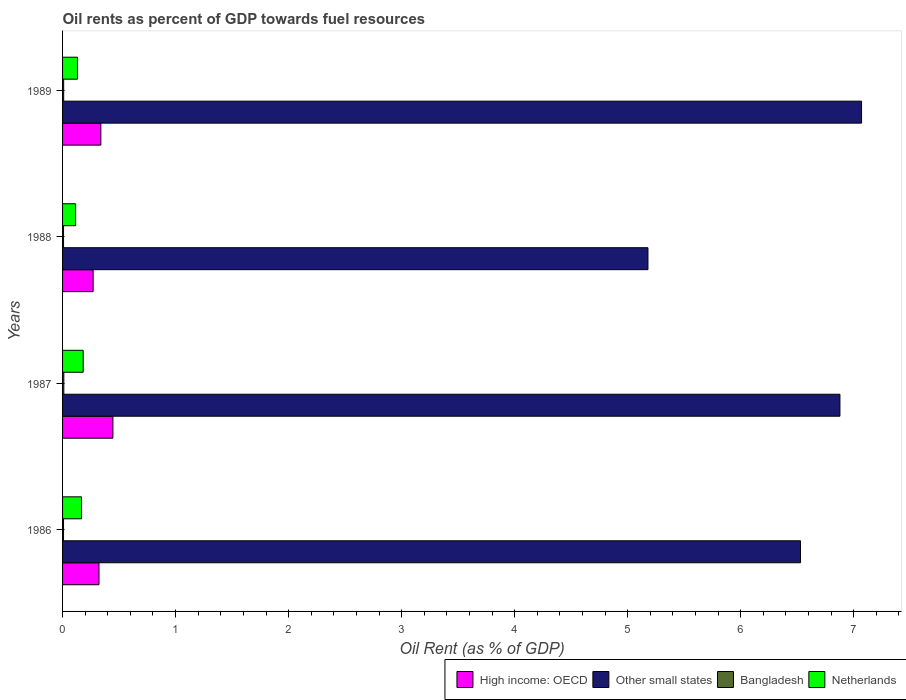How many different coloured bars are there?
Ensure brevity in your answer.  4. How many groups of bars are there?
Give a very brief answer. 4. How many bars are there on the 2nd tick from the bottom?
Offer a terse response. 4. In how many cases, is the number of bars for a given year not equal to the number of legend labels?
Your answer should be compact. 0. What is the oil rent in Netherlands in 1987?
Offer a terse response. 0.18. Across all years, what is the maximum oil rent in Other small states?
Give a very brief answer. 7.07. Across all years, what is the minimum oil rent in Other small states?
Provide a succinct answer. 5.18. In which year was the oil rent in Bangladesh maximum?
Your answer should be very brief. 1987. In which year was the oil rent in High income: OECD minimum?
Keep it short and to the point. 1988. What is the total oil rent in High income: OECD in the graph?
Your response must be concise. 1.38. What is the difference between the oil rent in Other small states in 1986 and that in 1989?
Keep it short and to the point. -0.54. What is the difference between the oil rent in Netherlands in 1988 and the oil rent in High income: OECD in 1986?
Your response must be concise. -0.21. What is the average oil rent in Netherlands per year?
Offer a very short reply. 0.15. In the year 1987, what is the difference between the oil rent in Netherlands and oil rent in Other small states?
Offer a terse response. -6.7. In how many years, is the oil rent in Other small states greater than 7 %?
Give a very brief answer. 1. What is the ratio of the oil rent in Netherlands in 1986 to that in 1988?
Your response must be concise. 1.45. Is the difference between the oil rent in Netherlands in 1986 and 1989 greater than the difference between the oil rent in Other small states in 1986 and 1989?
Your answer should be very brief. Yes. What is the difference between the highest and the second highest oil rent in Other small states?
Provide a short and direct response. 0.19. What is the difference between the highest and the lowest oil rent in High income: OECD?
Offer a terse response. 0.18. In how many years, is the oil rent in Bangladesh greater than the average oil rent in Bangladesh taken over all years?
Your answer should be compact. 2. What does the 1st bar from the top in 1988 represents?
Offer a very short reply. Netherlands. What does the 2nd bar from the bottom in 1986 represents?
Your answer should be compact. Other small states. Is it the case that in every year, the sum of the oil rent in High income: OECD and oil rent in Other small states is greater than the oil rent in Bangladesh?
Your answer should be very brief. Yes. How many bars are there?
Give a very brief answer. 16. Are all the bars in the graph horizontal?
Provide a short and direct response. Yes. How many years are there in the graph?
Keep it short and to the point. 4. Are the values on the major ticks of X-axis written in scientific E-notation?
Provide a short and direct response. No. Does the graph contain any zero values?
Keep it short and to the point. No. Does the graph contain grids?
Provide a succinct answer. No. Where does the legend appear in the graph?
Provide a short and direct response. Bottom right. How are the legend labels stacked?
Your answer should be compact. Horizontal. What is the title of the graph?
Make the answer very short. Oil rents as percent of GDP towards fuel resources. What is the label or title of the X-axis?
Provide a short and direct response. Oil Rent (as % of GDP). What is the Oil Rent (as % of GDP) of High income: OECD in 1986?
Offer a very short reply. 0.32. What is the Oil Rent (as % of GDP) of Other small states in 1986?
Provide a succinct answer. 6.53. What is the Oil Rent (as % of GDP) of Bangladesh in 1986?
Make the answer very short. 0.01. What is the Oil Rent (as % of GDP) in Netherlands in 1986?
Ensure brevity in your answer.  0.17. What is the Oil Rent (as % of GDP) in High income: OECD in 1987?
Ensure brevity in your answer.  0.45. What is the Oil Rent (as % of GDP) in Other small states in 1987?
Provide a short and direct response. 6.88. What is the Oil Rent (as % of GDP) in Bangladesh in 1987?
Give a very brief answer. 0.01. What is the Oil Rent (as % of GDP) in Netherlands in 1987?
Give a very brief answer. 0.18. What is the Oil Rent (as % of GDP) in High income: OECD in 1988?
Ensure brevity in your answer.  0.27. What is the Oil Rent (as % of GDP) of Other small states in 1988?
Your answer should be very brief. 5.18. What is the Oil Rent (as % of GDP) in Bangladesh in 1988?
Keep it short and to the point. 0.01. What is the Oil Rent (as % of GDP) of Netherlands in 1988?
Offer a terse response. 0.12. What is the Oil Rent (as % of GDP) in High income: OECD in 1989?
Give a very brief answer. 0.34. What is the Oil Rent (as % of GDP) in Other small states in 1989?
Provide a short and direct response. 7.07. What is the Oil Rent (as % of GDP) of Bangladesh in 1989?
Offer a very short reply. 0.01. What is the Oil Rent (as % of GDP) in Netherlands in 1989?
Make the answer very short. 0.13. Across all years, what is the maximum Oil Rent (as % of GDP) of High income: OECD?
Provide a short and direct response. 0.45. Across all years, what is the maximum Oil Rent (as % of GDP) in Other small states?
Provide a short and direct response. 7.07. Across all years, what is the maximum Oil Rent (as % of GDP) of Bangladesh?
Offer a terse response. 0.01. Across all years, what is the maximum Oil Rent (as % of GDP) in Netherlands?
Your answer should be compact. 0.18. Across all years, what is the minimum Oil Rent (as % of GDP) in High income: OECD?
Your answer should be very brief. 0.27. Across all years, what is the minimum Oil Rent (as % of GDP) of Other small states?
Provide a short and direct response. 5.18. Across all years, what is the minimum Oil Rent (as % of GDP) in Bangladesh?
Your answer should be compact. 0.01. Across all years, what is the minimum Oil Rent (as % of GDP) of Netherlands?
Make the answer very short. 0.12. What is the total Oil Rent (as % of GDP) in High income: OECD in the graph?
Offer a very short reply. 1.38. What is the total Oil Rent (as % of GDP) in Other small states in the graph?
Ensure brevity in your answer.  25.65. What is the total Oil Rent (as % of GDP) of Bangladesh in the graph?
Your answer should be compact. 0.04. What is the total Oil Rent (as % of GDP) of Netherlands in the graph?
Your answer should be compact. 0.6. What is the difference between the Oil Rent (as % of GDP) in High income: OECD in 1986 and that in 1987?
Give a very brief answer. -0.12. What is the difference between the Oil Rent (as % of GDP) of Other small states in 1986 and that in 1987?
Make the answer very short. -0.35. What is the difference between the Oil Rent (as % of GDP) in Bangladesh in 1986 and that in 1987?
Your answer should be compact. -0. What is the difference between the Oil Rent (as % of GDP) of Netherlands in 1986 and that in 1987?
Your answer should be compact. -0.01. What is the difference between the Oil Rent (as % of GDP) in High income: OECD in 1986 and that in 1988?
Your response must be concise. 0.05. What is the difference between the Oil Rent (as % of GDP) in Other small states in 1986 and that in 1988?
Keep it short and to the point. 1.35. What is the difference between the Oil Rent (as % of GDP) in Bangladesh in 1986 and that in 1988?
Make the answer very short. -0. What is the difference between the Oil Rent (as % of GDP) in Netherlands in 1986 and that in 1988?
Offer a terse response. 0.05. What is the difference between the Oil Rent (as % of GDP) of High income: OECD in 1986 and that in 1989?
Provide a short and direct response. -0.02. What is the difference between the Oil Rent (as % of GDP) of Other small states in 1986 and that in 1989?
Your answer should be compact. -0.54. What is the difference between the Oil Rent (as % of GDP) in Bangladesh in 1986 and that in 1989?
Offer a very short reply. -0. What is the difference between the Oil Rent (as % of GDP) in Netherlands in 1986 and that in 1989?
Your answer should be compact. 0.04. What is the difference between the Oil Rent (as % of GDP) in High income: OECD in 1987 and that in 1988?
Your response must be concise. 0.17. What is the difference between the Oil Rent (as % of GDP) in Other small states in 1987 and that in 1988?
Provide a succinct answer. 1.7. What is the difference between the Oil Rent (as % of GDP) of Bangladesh in 1987 and that in 1988?
Your answer should be compact. 0. What is the difference between the Oil Rent (as % of GDP) in Netherlands in 1987 and that in 1988?
Give a very brief answer. 0.07. What is the difference between the Oil Rent (as % of GDP) in High income: OECD in 1987 and that in 1989?
Your response must be concise. 0.11. What is the difference between the Oil Rent (as % of GDP) of Other small states in 1987 and that in 1989?
Ensure brevity in your answer.  -0.19. What is the difference between the Oil Rent (as % of GDP) of Bangladesh in 1987 and that in 1989?
Your response must be concise. 0. What is the difference between the Oil Rent (as % of GDP) of Netherlands in 1987 and that in 1989?
Your answer should be compact. 0.05. What is the difference between the Oil Rent (as % of GDP) in High income: OECD in 1988 and that in 1989?
Make the answer very short. -0.07. What is the difference between the Oil Rent (as % of GDP) in Other small states in 1988 and that in 1989?
Make the answer very short. -1.89. What is the difference between the Oil Rent (as % of GDP) of Bangladesh in 1988 and that in 1989?
Provide a succinct answer. -0. What is the difference between the Oil Rent (as % of GDP) in Netherlands in 1988 and that in 1989?
Your response must be concise. -0.02. What is the difference between the Oil Rent (as % of GDP) of High income: OECD in 1986 and the Oil Rent (as % of GDP) of Other small states in 1987?
Ensure brevity in your answer.  -6.56. What is the difference between the Oil Rent (as % of GDP) in High income: OECD in 1986 and the Oil Rent (as % of GDP) in Bangladesh in 1987?
Give a very brief answer. 0.31. What is the difference between the Oil Rent (as % of GDP) of High income: OECD in 1986 and the Oil Rent (as % of GDP) of Netherlands in 1987?
Provide a short and direct response. 0.14. What is the difference between the Oil Rent (as % of GDP) of Other small states in 1986 and the Oil Rent (as % of GDP) of Bangladesh in 1987?
Ensure brevity in your answer.  6.52. What is the difference between the Oil Rent (as % of GDP) of Other small states in 1986 and the Oil Rent (as % of GDP) of Netherlands in 1987?
Provide a succinct answer. 6.35. What is the difference between the Oil Rent (as % of GDP) in Bangladesh in 1986 and the Oil Rent (as % of GDP) in Netherlands in 1987?
Offer a very short reply. -0.17. What is the difference between the Oil Rent (as % of GDP) in High income: OECD in 1986 and the Oil Rent (as % of GDP) in Other small states in 1988?
Make the answer very short. -4.86. What is the difference between the Oil Rent (as % of GDP) in High income: OECD in 1986 and the Oil Rent (as % of GDP) in Bangladesh in 1988?
Offer a terse response. 0.31. What is the difference between the Oil Rent (as % of GDP) of High income: OECD in 1986 and the Oil Rent (as % of GDP) of Netherlands in 1988?
Your answer should be compact. 0.21. What is the difference between the Oil Rent (as % of GDP) of Other small states in 1986 and the Oil Rent (as % of GDP) of Bangladesh in 1988?
Offer a very short reply. 6.52. What is the difference between the Oil Rent (as % of GDP) of Other small states in 1986 and the Oil Rent (as % of GDP) of Netherlands in 1988?
Provide a short and direct response. 6.41. What is the difference between the Oil Rent (as % of GDP) of Bangladesh in 1986 and the Oil Rent (as % of GDP) of Netherlands in 1988?
Ensure brevity in your answer.  -0.11. What is the difference between the Oil Rent (as % of GDP) of High income: OECD in 1986 and the Oil Rent (as % of GDP) of Other small states in 1989?
Your answer should be very brief. -6.75. What is the difference between the Oil Rent (as % of GDP) in High income: OECD in 1986 and the Oil Rent (as % of GDP) in Bangladesh in 1989?
Make the answer very short. 0.31. What is the difference between the Oil Rent (as % of GDP) of High income: OECD in 1986 and the Oil Rent (as % of GDP) of Netherlands in 1989?
Ensure brevity in your answer.  0.19. What is the difference between the Oil Rent (as % of GDP) of Other small states in 1986 and the Oil Rent (as % of GDP) of Bangladesh in 1989?
Offer a very short reply. 6.52. What is the difference between the Oil Rent (as % of GDP) of Other small states in 1986 and the Oil Rent (as % of GDP) of Netherlands in 1989?
Ensure brevity in your answer.  6.4. What is the difference between the Oil Rent (as % of GDP) in Bangladesh in 1986 and the Oil Rent (as % of GDP) in Netherlands in 1989?
Make the answer very short. -0.12. What is the difference between the Oil Rent (as % of GDP) in High income: OECD in 1987 and the Oil Rent (as % of GDP) in Other small states in 1988?
Make the answer very short. -4.73. What is the difference between the Oil Rent (as % of GDP) in High income: OECD in 1987 and the Oil Rent (as % of GDP) in Bangladesh in 1988?
Your answer should be very brief. 0.44. What is the difference between the Oil Rent (as % of GDP) of High income: OECD in 1987 and the Oil Rent (as % of GDP) of Netherlands in 1988?
Your answer should be very brief. 0.33. What is the difference between the Oil Rent (as % of GDP) in Other small states in 1987 and the Oil Rent (as % of GDP) in Bangladesh in 1988?
Offer a terse response. 6.87. What is the difference between the Oil Rent (as % of GDP) of Other small states in 1987 and the Oil Rent (as % of GDP) of Netherlands in 1988?
Provide a succinct answer. 6.76. What is the difference between the Oil Rent (as % of GDP) of Bangladesh in 1987 and the Oil Rent (as % of GDP) of Netherlands in 1988?
Make the answer very short. -0.1. What is the difference between the Oil Rent (as % of GDP) of High income: OECD in 1987 and the Oil Rent (as % of GDP) of Other small states in 1989?
Ensure brevity in your answer.  -6.62. What is the difference between the Oil Rent (as % of GDP) in High income: OECD in 1987 and the Oil Rent (as % of GDP) in Bangladesh in 1989?
Your answer should be compact. 0.44. What is the difference between the Oil Rent (as % of GDP) of High income: OECD in 1987 and the Oil Rent (as % of GDP) of Netherlands in 1989?
Your answer should be compact. 0.31. What is the difference between the Oil Rent (as % of GDP) of Other small states in 1987 and the Oil Rent (as % of GDP) of Bangladesh in 1989?
Provide a short and direct response. 6.87. What is the difference between the Oil Rent (as % of GDP) of Other small states in 1987 and the Oil Rent (as % of GDP) of Netherlands in 1989?
Provide a short and direct response. 6.75. What is the difference between the Oil Rent (as % of GDP) in Bangladesh in 1987 and the Oil Rent (as % of GDP) in Netherlands in 1989?
Your answer should be very brief. -0.12. What is the difference between the Oil Rent (as % of GDP) in High income: OECD in 1988 and the Oil Rent (as % of GDP) in Other small states in 1989?
Give a very brief answer. -6.8. What is the difference between the Oil Rent (as % of GDP) in High income: OECD in 1988 and the Oil Rent (as % of GDP) in Bangladesh in 1989?
Your answer should be compact. 0.26. What is the difference between the Oil Rent (as % of GDP) in High income: OECD in 1988 and the Oil Rent (as % of GDP) in Netherlands in 1989?
Your answer should be compact. 0.14. What is the difference between the Oil Rent (as % of GDP) in Other small states in 1988 and the Oil Rent (as % of GDP) in Bangladesh in 1989?
Keep it short and to the point. 5.17. What is the difference between the Oil Rent (as % of GDP) in Other small states in 1988 and the Oil Rent (as % of GDP) in Netherlands in 1989?
Give a very brief answer. 5.05. What is the difference between the Oil Rent (as % of GDP) in Bangladesh in 1988 and the Oil Rent (as % of GDP) in Netherlands in 1989?
Provide a short and direct response. -0.12. What is the average Oil Rent (as % of GDP) of High income: OECD per year?
Provide a short and direct response. 0.34. What is the average Oil Rent (as % of GDP) in Other small states per year?
Your answer should be very brief. 6.41. What is the average Oil Rent (as % of GDP) in Bangladesh per year?
Make the answer very short. 0.01. What is the average Oil Rent (as % of GDP) of Netherlands per year?
Keep it short and to the point. 0.15. In the year 1986, what is the difference between the Oil Rent (as % of GDP) of High income: OECD and Oil Rent (as % of GDP) of Other small states?
Ensure brevity in your answer.  -6.21. In the year 1986, what is the difference between the Oil Rent (as % of GDP) in High income: OECD and Oil Rent (as % of GDP) in Bangladesh?
Give a very brief answer. 0.31. In the year 1986, what is the difference between the Oil Rent (as % of GDP) of High income: OECD and Oil Rent (as % of GDP) of Netherlands?
Ensure brevity in your answer.  0.15. In the year 1986, what is the difference between the Oil Rent (as % of GDP) in Other small states and Oil Rent (as % of GDP) in Bangladesh?
Your answer should be compact. 6.52. In the year 1986, what is the difference between the Oil Rent (as % of GDP) of Other small states and Oil Rent (as % of GDP) of Netherlands?
Your response must be concise. 6.36. In the year 1986, what is the difference between the Oil Rent (as % of GDP) of Bangladesh and Oil Rent (as % of GDP) of Netherlands?
Offer a terse response. -0.16. In the year 1987, what is the difference between the Oil Rent (as % of GDP) of High income: OECD and Oil Rent (as % of GDP) of Other small states?
Offer a terse response. -6.43. In the year 1987, what is the difference between the Oil Rent (as % of GDP) of High income: OECD and Oil Rent (as % of GDP) of Bangladesh?
Your response must be concise. 0.43. In the year 1987, what is the difference between the Oil Rent (as % of GDP) in High income: OECD and Oil Rent (as % of GDP) in Netherlands?
Offer a very short reply. 0.26. In the year 1987, what is the difference between the Oil Rent (as % of GDP) in Other small states and Oil Rent (as % of GDP) in Bangladesh?
Provide a succinct answer. 6.87. In the year 1987, what is the difference between the Oil Rent (as % of GDP) in Other small states and Oil Rent (as % of GDP) in Netherlands?
Your response must be concise. 6.7. In the year 1987, what is the difference between the Oil Rent (as % of GDP) of Bangladesh and Oil Rent (as % of GDP) of Netherlands?
Your answer should be compact. -0.17. In the year 1988, what is the difference between the Oil Rent (as % of GDP) in High income: OECD and Oil Rent (as % of GDP) in Other small states?
Give a very brief answer. -4.91. In the year 1988, what is the difference between the Oil Rent (as % of GDP) of High income: OECD and Oil Rent (as % of GDP) of Bangladesh?
Offer a very short reply. 0.26. In the year 1988, what is the difference between the Oil Rent (as % of GDP) of High income: OECD and Oil Rent (as % of GDP) of Netherlands?
Offer a very short reply. 0.15. In the year 1988, what is the difference between the Oil Rent (as % of GDP) of Other small states and Oil Rent (as % of GDP) of Bangladesh?
Offer a very short reply. 5.17. In the year 1988, what is the difference between the Oil Rent (as % of GDP) in Other small states and Oil Rent (as % of GDP) in Netherlands?
Provide a short and direct response. 5.06. In the year 1988, what is the difference between the Oil Rent (as % of GDP) in Bangladesh and Oil Rent (as % of GDP) in Netherlands?
Provide a short and direct response. -0.11. In the year 1989, what is the difference between the Oil Rent (as % of GDP) in High income: OECD and Oil Rent (as % of GDP) in Other small states?
Your answer should be very brief. -6.73. In the year 1989, what is the difference between the Oil Rent (as % of GDP) of High income: OECD and Oil Rent (as % of GDP) of Bangladesh?
Your answer should be very brief. 0.33. In the year 1989, what is the difference between the Oil Rent (as % of GDP) of High income: OECD and Oil Rent (as % of GDP) of Netherlands?
Ensure brevity in your answer.  0.21. In the year 1989, what is the difference between the Oil Rent (as % of GDP) of Other small states and Oil Rent (as % of GDP) of Bangladesh?
Provide a succinct answer. 7.06. In the year 1989, what is the difference between the Oil Rent (as % of GDP) of Other small states and Oil Rent (as % of GDP) of Netherlands?
Make the answer very short. 6.94. In the year 1989, what is the difference between the Oil Rent (as % of GDP) in Bangladesh and Oil Rent (as % of GDP) in Netherlands?
Your response must be concise. -0.12. What is the ratio of the Oil Rent (as % of GDP) of High income: OECD in 1986 to that in 1987?
Offer a terse response. 0.72. What is the ratio of the Oil Rent (as % of GDP) in Other small states in 1986 to that in 1987?
Your answer should be compact. 0.95. What is the ratio of the Oil Rent (as % of GDP) in Bangladesh in 1986 to that in 1987?
Keep it short and to the point. 0.77. What is the ratio of the Oil Rent (as % of GDP) of Netherlands in 1986 to that in 1987?
Your answer should be very brief. 0.92. What is the ratio of the Oil Rent (as % of GDP) of High income: OECD in 1986 to that in 1988?
Ensure brevity in your answer.  1.19. What is the ratio of the Oil Rent (as % of GDP) of Other small states in 1986 to that in 1988?
Offer a very short reply. 1.26. What is the ratio of the Oil Rent (as % of GDP) in Bangladesh in 1986 to that in 1988?
Ensure brevity in your answer.  0.99. What is the ratio of the Oil Rent (as % of GDP) in Netherlands in 1986 to that in 1988?
Provide a short and direct response. 1.45. What is the ratio of the Oil Rent (as % of GDP) in High income: OECD in 1986 to that in 1989?
Offer a very short reply. 0.95. What is the ratio of the Oil Rent (as % of GDP) in Other small states in 1986 to that in 1989?
Provide a succinct answer. 0.92. What is the ratio of the Oil Rent (as % of GDP) of Bangladesh in 1986 to that in 1989?
Provide a succinct answer. 0.88. What is the ratio of the Oil Rent (as % of GDP) of Netherlands in 1986 to that in 1989?
Your answer should be very brief. 1.27. What is the ratio of the Oil Rent (as % of GDP) in High income: OECD in 1987 to that in 1988?
Make the answer very short. 1.65. What is the ratio of the Oil Rent (as % of GDP) in Other small states in 1987 to that in 1988?
Give a very brief answer. 1.33. What is the ratio of the Oil Rent (as % of GDP) in Bangladesh in 1987 to that in 1988?
Your answer should be compact. 1.28. What is the ratio of the Oil Rent (as % of GDP) in Netherlands in 1987 to that in 1988?
Ensure brevity in your answer.  1.58. What is the ratio of the Oil Rent (as % of GDP) of High income: OECD in 1987 to that in 1989?
Make the answer very short. 1.32. What is the ratio of the Oil Rent (as % of GDP) of Other small states in 1987 to that in 1989?
Your answer should be compact. 0.97. What is the ratio of the Oil Rent (as % of GDP) of Bangladesh in 1987 to that in 1989?
Your response must be concise. 1.15. What is the ratio of the Oil Rent (as % of GDP) in Netherlands in 1987 to that in 1989?
Keep it short and to the point. 1.38. What is the ratio of the Oil Rent (as % of GDP) in High income: OECD in 1988 to that in 1989?
Provide a succinct answer. 0.8. What is the ratio of the Oil Rent (as % of GDP) of Other small states in 1988 to that in 1989?
Provide a short and direct response. 0.73. What is the ratio of the Oil Rent (as % of GDP) of Bangladesh in 1988 to that in 1989?
Offer a very short reply. 0.9. What is the ratio of the Oil Rent (as % of GDP) in Netherlands in 1988 to that in 1989?
Provide a succinct answer. 0.88. What is the difference between the highest and the second highest Oil Rent (as % of GDP) in High income: OECD?
Offer a terse response. 0.11. What is the difference between the highest and the second highest Oil Rent (as % of GDP) of Other small states?
Your response must be concise. 0.19. What is the difference between the highest and the second highest Oil Rent (as % of GDP) in Bangladesh?
Ensure brevity in your answer.  0. What is the difference between the highest and the second highest Oil Rent (as % of GDP) in Netherlands?
Your answer should be compact. 0.01. What is the difference between the highest and the lowest Oil Rent (as % of GDP) in High income: OECD?
Your response must be concise. 0.17. What is the difference between the highest and the lowest Oil Rent (as % of GDP) in Other small states?
Offer a terse response. 1.89. What is the difference between the highest and the lowest Oil Rent (as % of GDP) of Bangladesh?
Offer a very short reply. 0. What is the difference between the highest and the lowest Oil Rent (as % of GDP) of Netherlands?
Keep it short and to the point. 0.07. 